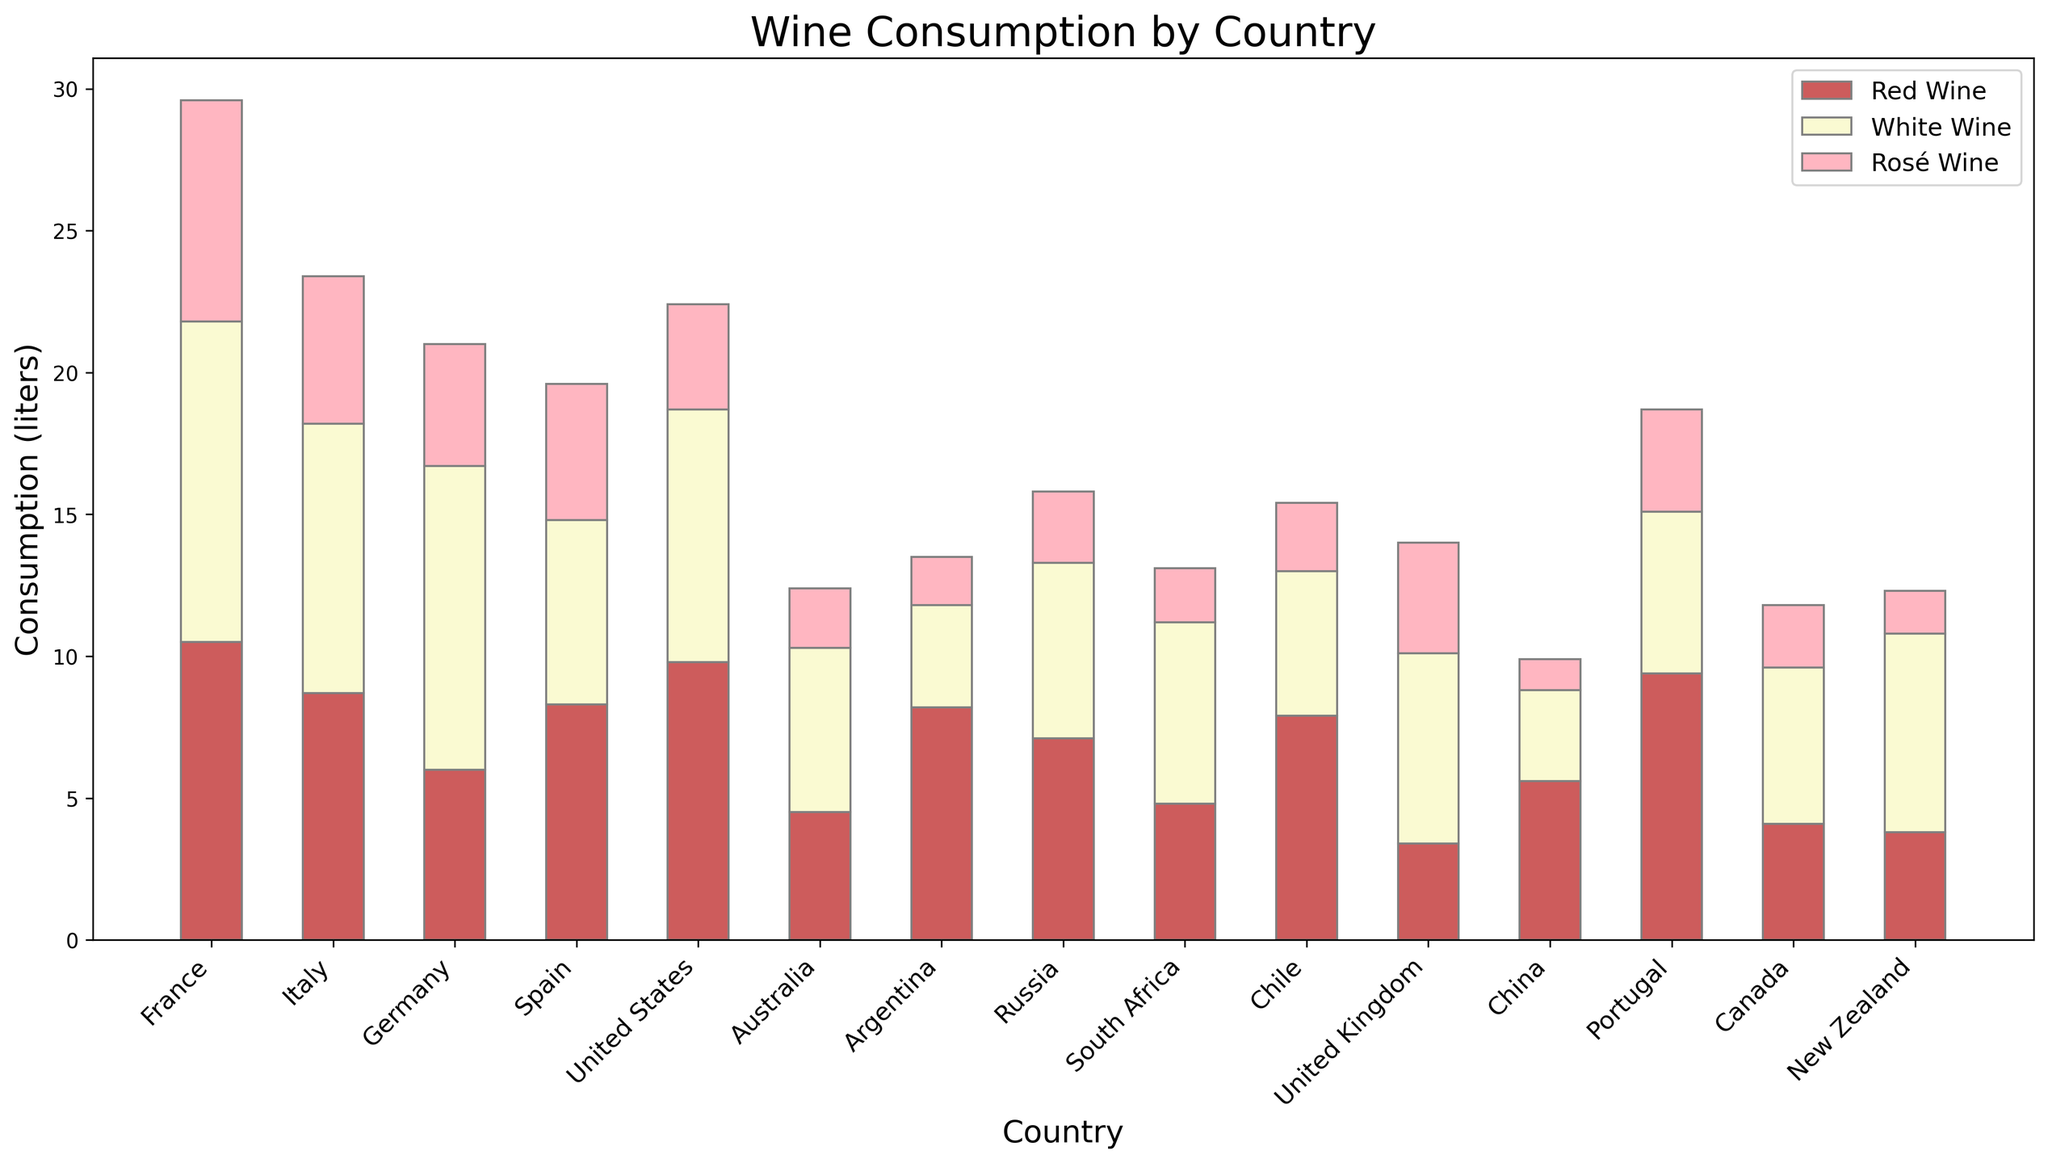What's the total wine consumption in the United States? To find the total wine consumption in the United States, sum the values of red, white, and rosé wine: 9.8 (red) + 8.9 (white) + 3.7 (rosé) = 22.4 liters.
Answer: 22.4 liters Which country consumes the most red wine? Look at the heights of the red sections of the bars and find the tallest one. France has the tallest red section with 10.5 liters.
Answer: France How does Russia's white wine consumption compare to Germany's? Compare the height of the white sections of Russia and Germany. Russia consumes 6.2 liters while Germany consumes 10.7 liters, so Germany consumes more white wine.
Answer: Germany consumes more What's the difference in rosé wine consumption between Spain and Argentina? Subtract the rosé wine consumption of Argentina from Spain: 4.8 (Spain) - 1.7 (Argentina) = 3.1 liters.
Answer: 3.1 liters What is the average total wine consumption for France, Italy, and Spain? First, calculate the total consumption for each country: France 29.6 (10.5+11.3+7.8), Italy 23.4 (8.7+9.5+5.2), Spain 19.6 (8.3+6.5+4.8). Then, find the average of these values: (29.6 + 23.4 + 19.6)/3 = 24.2 liters.
Answer: 24.2 liters Which country has the smallest consumption of rosé wine? Look for the shortest rosé section among all countries. China has the smallest amount with 1.1 liters.
Answer: China Compare total wine consumption between South Africa and Australia. Which country has higher consumption? Calculate the total consumption for each country: Australia 12.4 (4.5+5.8+2.1), South Africa 13.1 (4.8+6.4+1.9). South Africa consumes more wine (13.1 liters vs. 12.4 liters).
Answer: South Africa What's the sum of red and rosé wine consumption in Portugal? Add the values for red and rosé wine in Portugal: 9.4 (red) + 3.6 (rosé) = 13.0 liters.
Answer: 13.0 liters Which type of wine does Argentina consume the least? Compare red, white, and rosé values for Argentina. The smallest value is rosé wine consumption, with 1.7 liters.
Answer: Rosé wine What is the white wine consumption in Canada relative to Portugal? Compare the white wine consumption values: Canada 5.5 liters, Portugal 5.7 liters. Portugal consumes slightly more white wine than Canada.
Answer: Portugal consumes more 